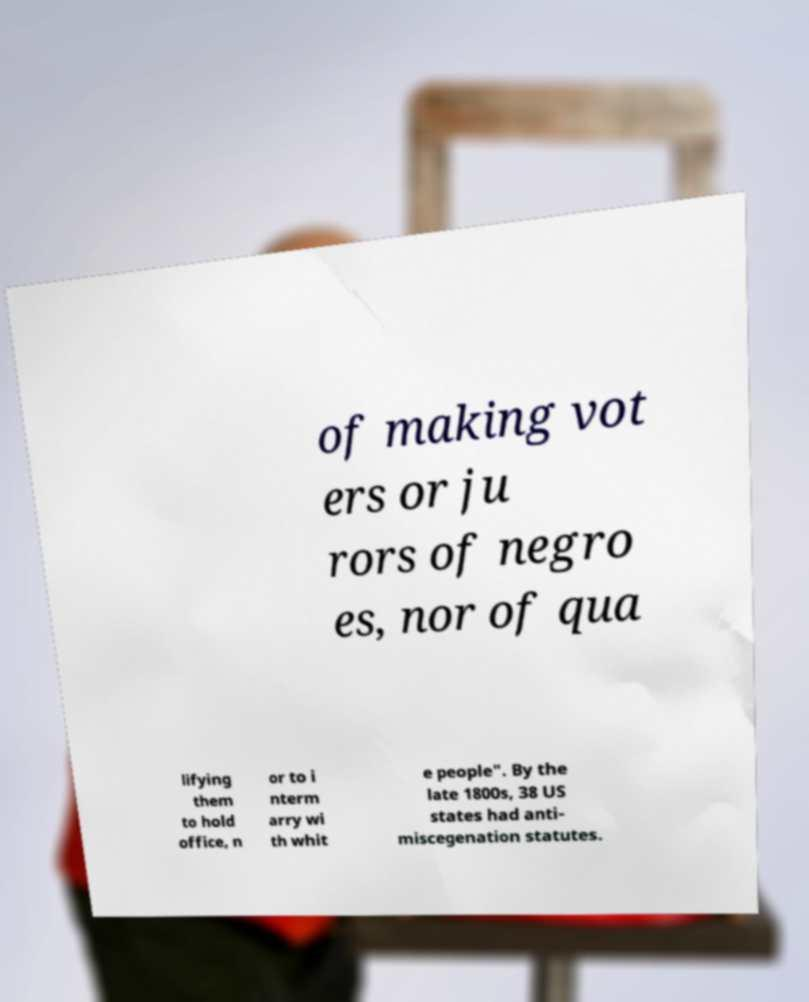Could you extract and type out the text from this image? of making vot ers or ju rors of negro es, nor of qua lifying them to hold office, n or to i nterm arry wi th whit e people". By the late 1800s, 38 US states had anti- miscegenation statutes. 